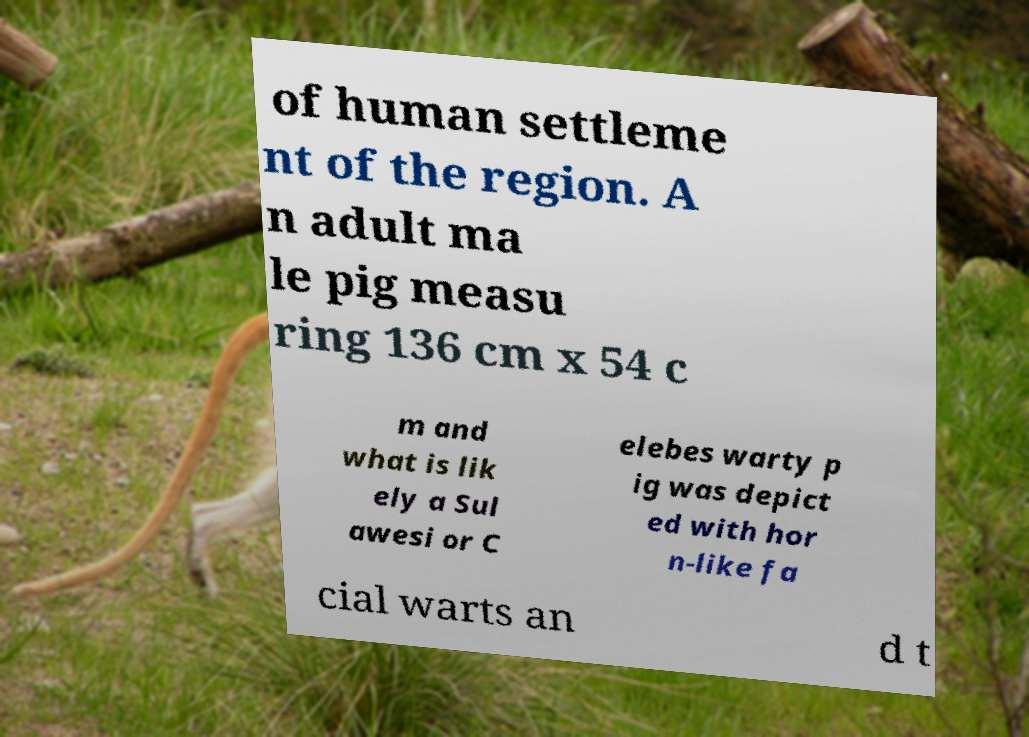Please identify and transcribe the text found in this image. of human settleme nt of the region. A n adult ma le pig measu ring 136 cm x 54 c m and what is lik ely a Sul awesi or C elebes warty p ig was depict ed with hor n-like fa cial warts an d t 